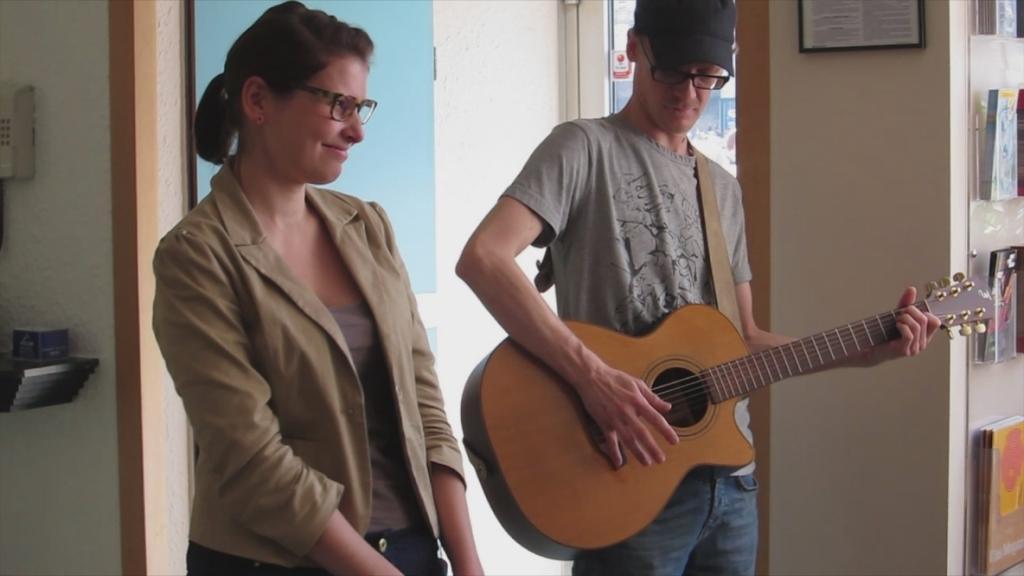Can you describe this image briefly? There are two persons. On the right side we have a man. His playing a guitar and his wearing a cap. On the left side we have a woman. She is smiling. In the background we can see posters,window. 